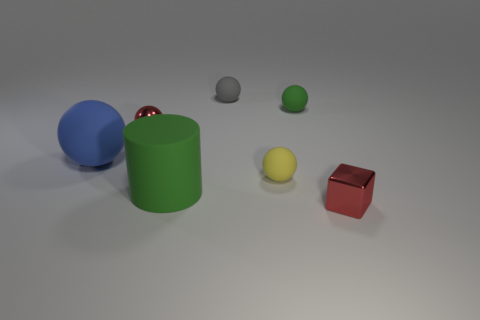Subtract all small green balls. How many balls are left? 4 Add 1 cubes. How many objects exist? 8 Subtract all gray spheres. How many spheres are left? 4 Subtract all balls. How many objects are left? 2 Subtract 3 spheres. How many spheres are left? 2 Subtract all yellow matte things. Subtract all small metallic objects. How many objects are left? 4 Add 4 big green matte things. How many big green matte things are left? 5 Add 1 cyan metal cylinders. How many cyan metal cylinders exist? 1 Subtract 1 gray balls. How many objects are left? 6 Subtract all blue blocks. Subtract all purple spheres. How many blocks are left? 1 